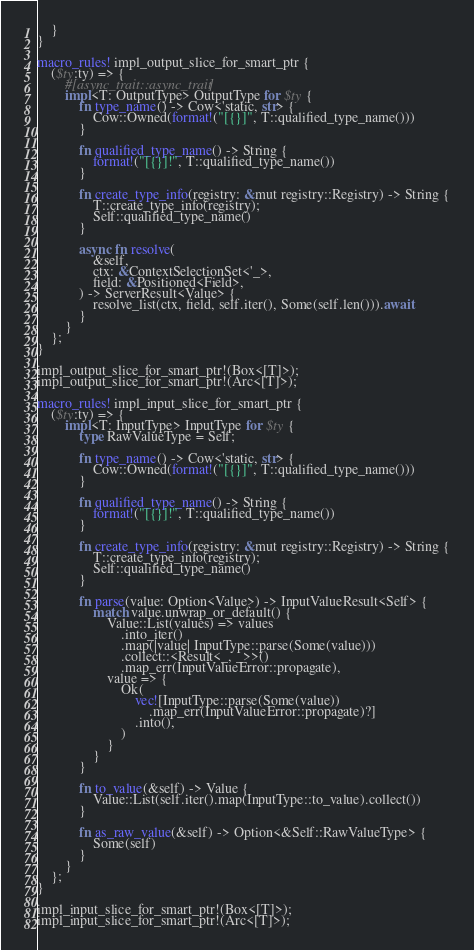<code> <loc_0><loc_0><loc_500><loc_500><_Rust_>    }
}

macro_rules! impl_output_slice_for_smart_ptr {
    ($ty:ty) => {
        #[async_trait::async_trait]
        impl<T: OutputType> OutputType for $ty {
            fn type_name() -> Cow<'static, str> {
                Cow::Owned(format!("[{}]", T::qualified_type_name()))
            }

            fn qualified_type_name() -> String {
                format!("[{}]!", T::qualified_type_name())
            }

            fn create_type_info(registry: &mut registry::Registry) -> String {
                T::create_type_info(registry);
                Self::qualified_type_name()
            }

            async fn resolve(
                &self,
                ctx: &ContextSelectionSet<'_>,
                field: &Positioned<Field>,
            ) -> ServerResult<Value> {
                resolve_list(ctx, field, self.iter(), Some(self.len())).await
            }
        }
    };
}

impl_output_slice_for_smart_ptr!(Box<[T]>);
impl_output_slice_for_smart_ptr!(Arc<[T]>);

macro_rules! impl_input_slice_for_smart_ptr {
    ($ty:ty) => {
        impl<T: InputType> InputType for $ty {
            type RawValueType = Self;

            fn type_name() -> Cow<'static, str> {
                Cow::Owned(format!("[{}]", T::qualified_type_name()))
            }

            fn qualified_type_name() -> String {
                format!("[{}]!", T::qualified_type_name())
            }

            fn create_type_info(registry: &mut registry::Registry) -> String {
                T::create_type_info(registry);
                Self::qualified_type_name()
            }

            fn parse(value: Option<Value>) -> InputValueResult<Self> {
                match value.unwrap_or_default() {
                    Value::List(values) => values
                        .into_iter()
                        .map(|value| InputType::parse(Some(value)))
                        .collect::<Result<_, _>>()
                        .map_err(InputValueError::propagate),
                    value => {
                        Ok(
                            vec![InputType::parse(Some(value))
                                .map_err(InputValueError::propagate)?]
                            .into(),
                        )
                    }
                }
            }

            fn to_value(&self) -> Value {
                Value::List(self.iter().map(InputType::to_value).collect())
            }

            fn as_raw_value(&self) -> Option<&Self::RawValueType> {
                Some(self)
            }
        }
    };
}

impl_input_slice_for_smart_ptr!(Box<[T]>);
impl_input_slice_for_smart_ptr!(Arc<[T]>);
</code> 